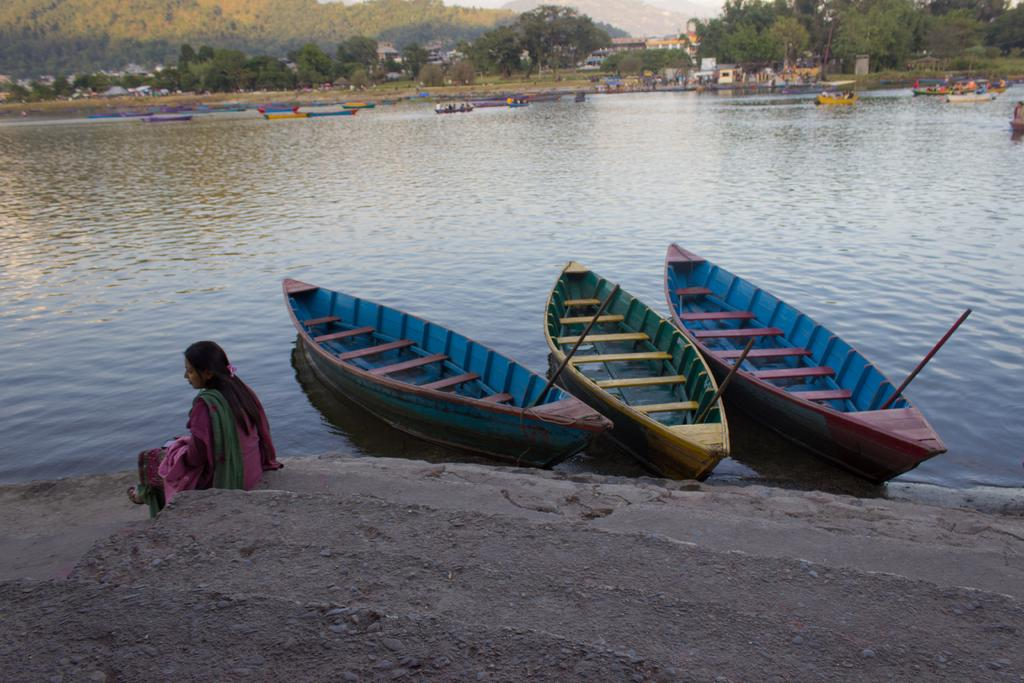What is the woman in the image doing? The woman is sitting on steps in the image. What can be seen on the water in the image? There are boats on the water in the image. What type of structures are visible in the image? There are buildings visible in the image. What type of vegetation is present in the image? There are trees in the image. Can you describe the unspecified objects in the image? Unfortunately, the facts provided do not specify the nature of these objects. What is visible in the background of the image? There are mountains visible in the background of the image. What type of feast is being prepared on the steps in the image? There is no indication of a feast or any food preparation in the image; the woman is simply sitting on the steps. What type of waves can be seen crashing against the boats in the image? There is no mention of waves in the image; the boats are on calm water. 